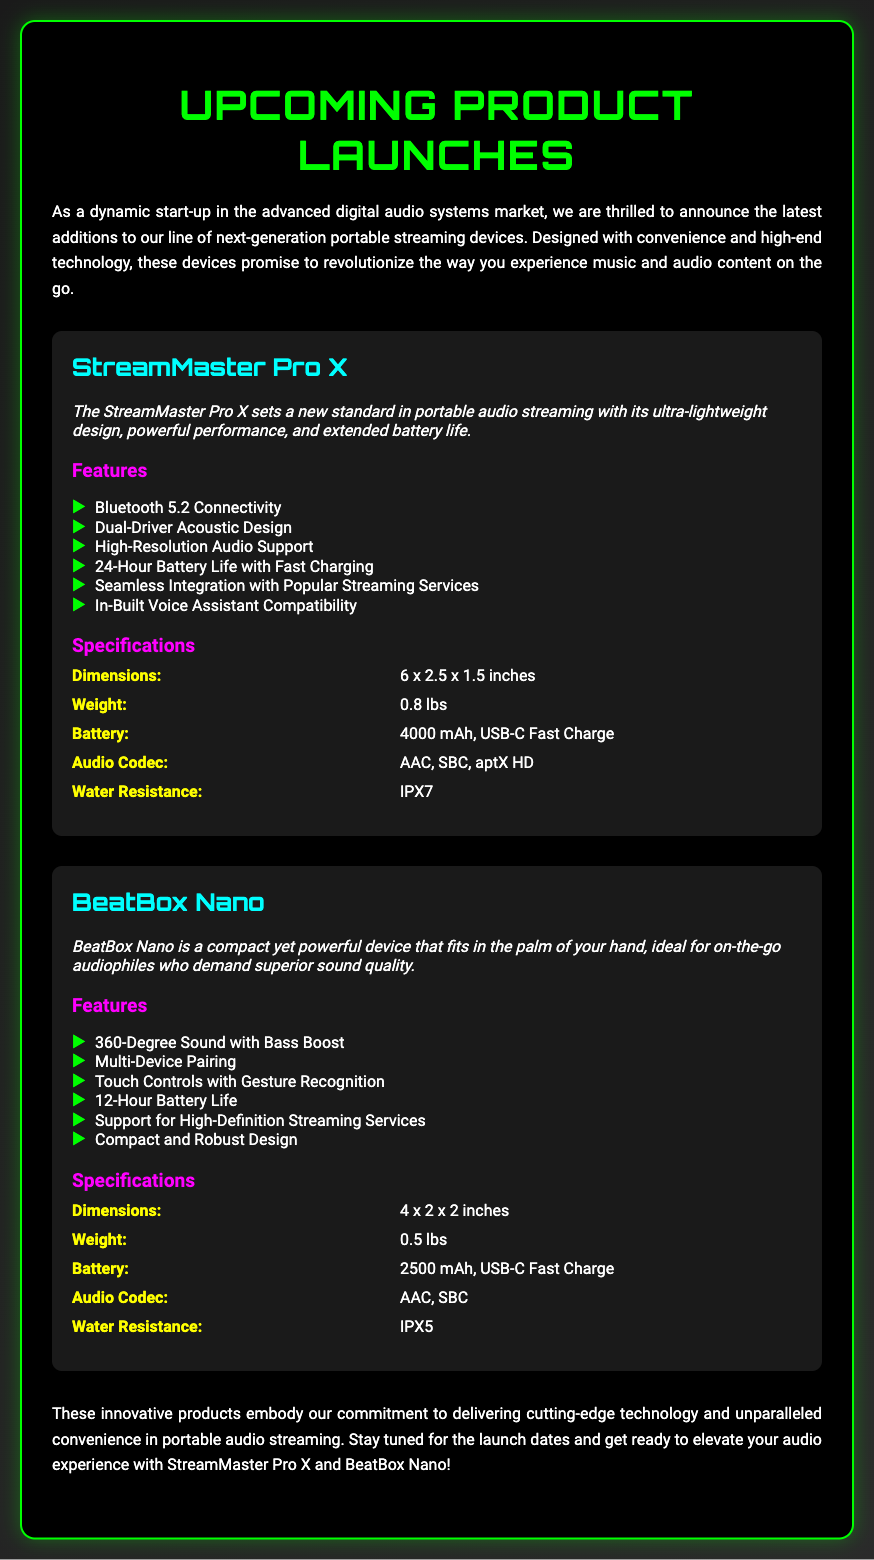What is the name of the first product? The first product mentioned in the Playbill is StreamMaster Pro X.
Answer: StreamMaster Pro X What type of audio support does the StreamMaster Pro X offer? The StreamMaster Pro X supports High-Resolution Audio.
Answer: High-Resolution Audio What is the battery life of the BeatBox Nano? The BeatBox Nano has a battery life of 12 hours.
Answer: 12-Hour Battery Life What is the water resistance rating for the StreamMaster Pro X? The StreamMaster Pro X has a water resistance rating of IPX7.
Answer: IPX7 How many products are mentioned in the document? There are two products mentioned in the document: StreamMaster Pro X and BeatBox Nano.
Answer: Two What feature allows users to control the BeatBox Nano? The BeatBox Nano has Touch Controls with Gesture Recognition.
Answer: Touch Controls with Gesture Recognition Which audio codec is supported by both products? Both products support the AAC audio codec.
Answer: AAC What is the weight of the BeatBox Nano? The weight of the BeatBox Nano is 0.5 lbs.
Answer: 0.5 lbs What is the primary focus of the upcoming product launches? The primary focus is on next-generation portable streaming devices.
Answer: Portable streaming devices 